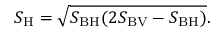<formula> <loc_0><loc_0><loc_500><loc_500>S _ { H } = \sqrt { S _ { B H } ( 2 S _ { B V } - S _ { B H } ) } .</formula> 